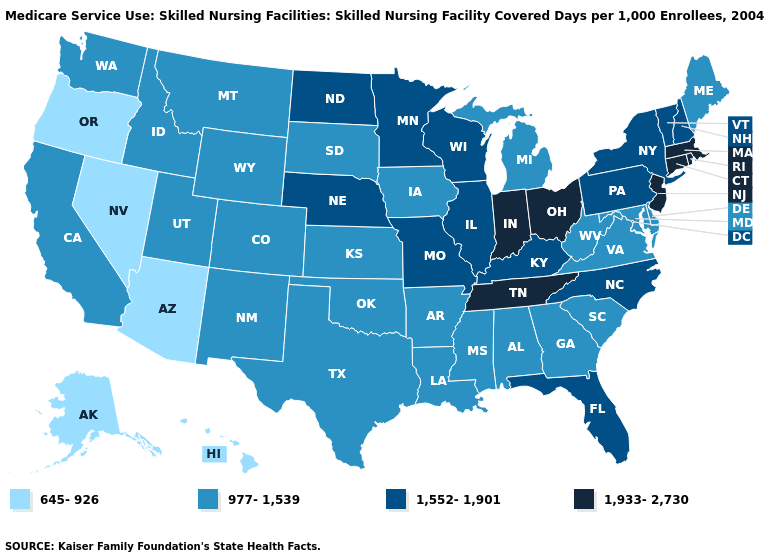Name the states that have a value in the range 1,933-2,730?
Short answer required. Connecticut, Indiana, Massachusetts, New Jersey, Ohio, Rhode Island, Tennessee. What is the value of Pennsylvania?
Keep it brief. 1,552-1,901. What is the value of Missouri?
Give a very brief answer. 1,552-1,901. How many symbols are there in the legend?
Short answer required. 4. Does Illinois have the same value as Kentucky?
Be succinct. Yes. How many symbols are there in the legend?
Write a very short answer. 4. Name the states that have a value in the range 977-1,539?
Answer briefly. Alabama, Arkansas, California, Colorado, Delaware, Georgia, Idaho, Iowa, Kansas, Louisiana, Maine, Maryland, Michigan, Mississippi, Montana, New Mexico, Oklahoma, South Carolina, South Dakota, Texas, Utah, Virginia, Washington, West Virginia, Wyoming. What is the highest value in the South ?
Give a very brief answer. 1,933-2,730. Which states have the highest value in the USA?
Concise answer only. Connecticut, Indiana, Massachusetts, New Jersey, Ohio, Rhode Island, Tennessee. What is the highest value in the USA?
Keep it brief. 1,933-2,730. What is the lowest value in the USA?
Keep it brief. 645-926. Name the states that have a value in the range 977-1,539?
Quick response, please. Alabama, Arkansas, California, Colorado, Delaware, Georgia, Idaho, Iowa, Kansas, Louisiana, Maine, Maryland, Michigan, Mississippi, Montana, New Mexico, Oklahoma, South Carolina, South Dakota, Texas, Utah, Virginia, Washington, West Virginia, Wyoming. Does Arkansas have a lower value than Illinois?
Short answer required. Yes. Which states have the highest value in the USA?
Answer briefly. Connecticut, Indiana, Massachusetts, New Jersey, Ohio, Rhode Island, Tennessee. 